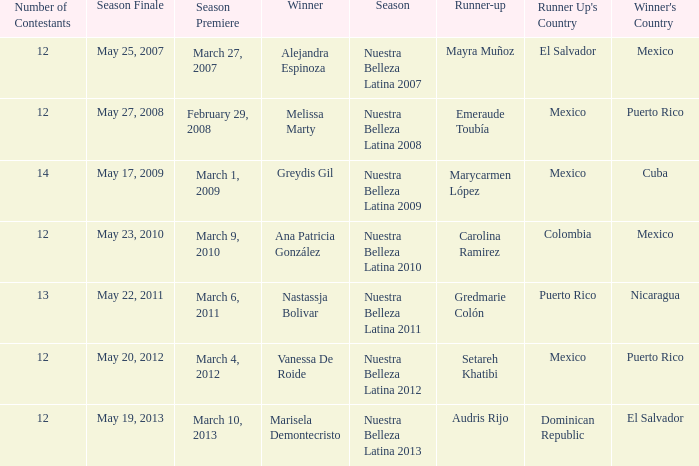Parse the table in full. {'header': ['Number of Contestants', 'Season Finale', 'Season Premiere', 'Winner', 'Season', 'Runner-up', "Runner Up's Country", "Winner's Country"], 'rows': [['12', 'May 25, 2007', 'March 27, 2007', 'Alejandra Espinoza', 'Nuestra Belleza Latina 2007', 'Mayra Muñoz', 'El Salvador', 'Mexico'], ['12', 'May 27, 2008', 'February 29, 2008', 'Melissa Marty', 'Nuestra Belleza Latina 2008', 'Emeraude Toubía', 'Mexico', 'Puerto Rico'], ['14', 'May 17, 2009', 'March 1, 2009', 'Greydis Gil', 'Nuestra Belleza Latina 2009', 'Marycarmen López', 'Mexico', 'Cuba'], ['12', 'May 23, 2010', 'March 9, 2010', 'Ana Patricia González', 'Nuestra Belleza Latina 2010', 'Carolina Ramirez', 'Colombia', 'Mexico'], ['13', 'May 22, 2011', 'March 6, 2011', 'Nastassja Bolivar', 'Nuestra Belleza Latina 2011', 'Gredmarie Colón', 'Puerto Rico', 'Nicaragua'], ['12', 'May 20, 2012', 'March 4, 2012', 'Vanessa De Roide', 'Nuestra Belleza Latina 2012', 'Setareh Khatibi', 'Mexico', 'Puerto Rico'], ['12', 'May 19, 2013', 'March 10, 2013', 'Marisela Demontecristo', 'Nuestra Belleza Latina 2013', 'Audris Rijo', 'Dominican Republic', 'El Salvador']]} How many contestants were there on March 1, 2009 during the season premiere? 14.0. 